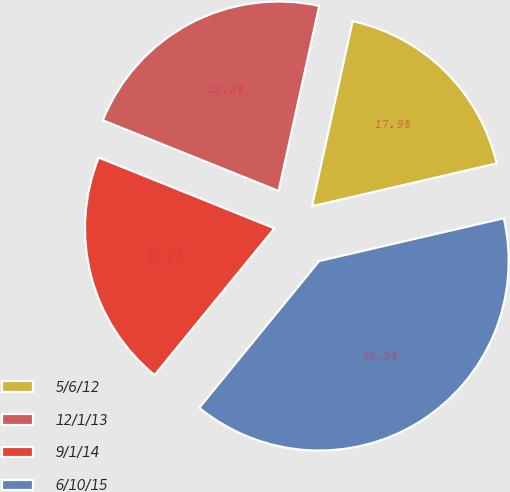Convert chart. <chart><loc_0><loc_0><loc_500><loc_500><pie_chart><fcel>5/6/12<fcel>12/1/13<fcel>9/1/14<fcel>6/10/15<nl><fcel>17.94%<fcel>22.35%<fcel>20.19%<fcel>39.53%<nl></chart> 